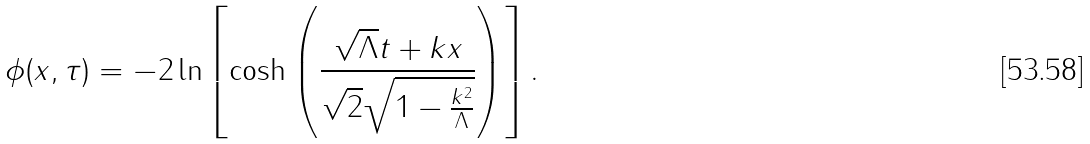Convert formula to latex. <formula><loc_0><loc_0><loc_500><loc_500>\phi ( x , \tau ) = - 2 \ln \left [ \cosh \left ( \frac { \sqrt { \Lambda } t + k x } { \sqrt { 2 } \sqrt { 1 - \frac { k ^ { 2 } } { \Lambda } } } \right ) \right ] .</formula> 